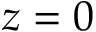Convert formula to latex. <formula><loc_0><loc_0><loc_500><loc_500>z = 0</formula> 